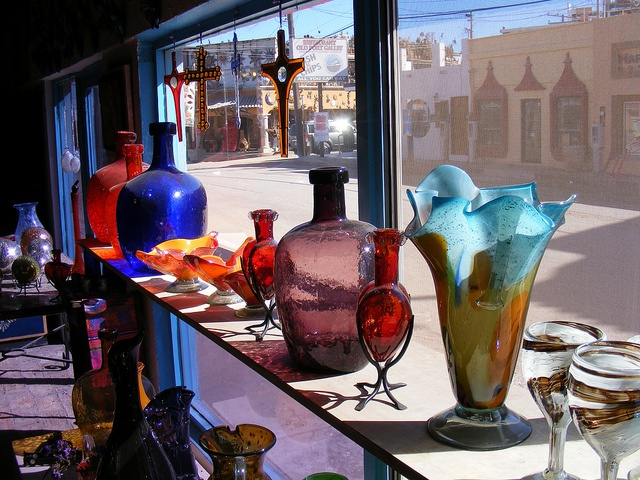Describe the objects in this image and their specific colors. I can see vase in black, olive, teal, and lightblue tones, vase in black, maroon, brown, and salmon tones, wine glass in black, darkgray, lightgray, maroon, and gray tones, vase in black, navy, darkblue, and blue tones, and wine glass in black, lightgray, darkgray, and gray tones in this image. 